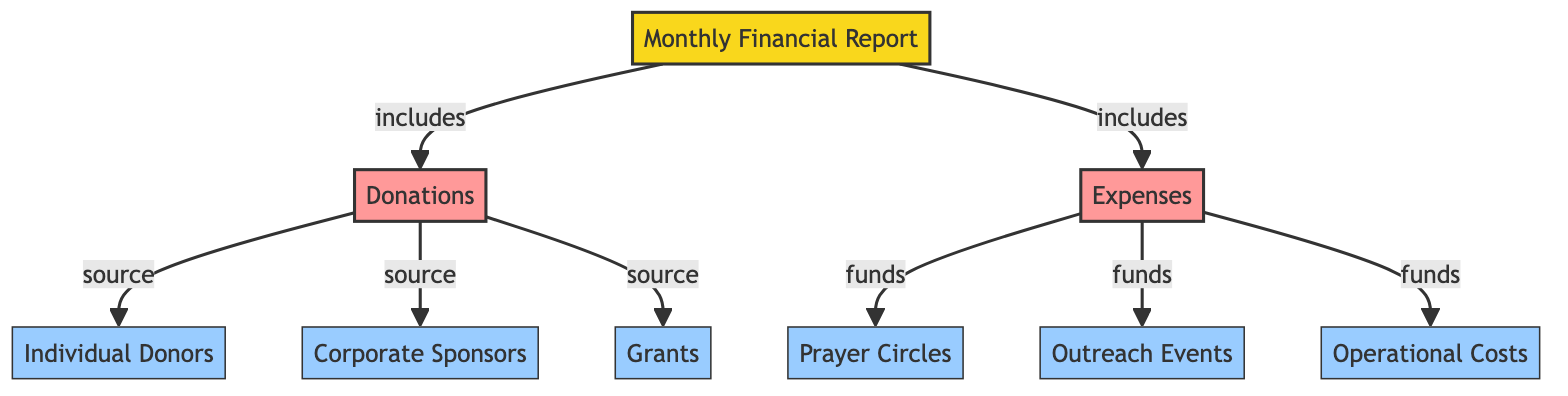What is represented at the top of the diagram? The top of the diagram is labeled "Monthly Financial Report," which serves as the root node and provides a summary of the financial status related to prayer-based community services.
Answer: Monthly Financial Report How many sources of donations are listed? The diagram lists three specific sources of donations: Individual Donors, Corporate Sponsors, and Grants, which are the child nodes under the Donations node.
Answer: Three What types of expenses are indicated in the diagram? The diagram specifies three categories of expenses: Prayer Circles, Outreach Events, and Operational Costs, which are connected to the Expenses node.
Answer: Prayer Circles, Outreach Events, Operational Costs What is the relationship between Donations and Individual Donors? The diagram indicates that Individual Donors are a source of Donations, showing a direct connection from the Individual Donors node to the Donations node.
Answer: Source Which node directly supports Outreach Events in the context of funding? The Expenses node funds Outreach Events, showing a direct connection from the Expenses node to the Outreach Events node.
Answer: Expenses What is the total number of nodes in the diagram? The diagram has a total of nine nodes, counting the root, the two main categories (Donations and Expenses), and the six sub-categories under them.
Answer: Nine How many edges directly connect from Donations to its sources? The diagram has three edges that connect Donations to its sources: one each to Individual Donors, Corporate Sponsors, and Grants.
Answer: Three What type of diagram is represented? The diagram is a flowchart, which visually represents relationships and categories through nodes and edges.
Answer: Flowchart 